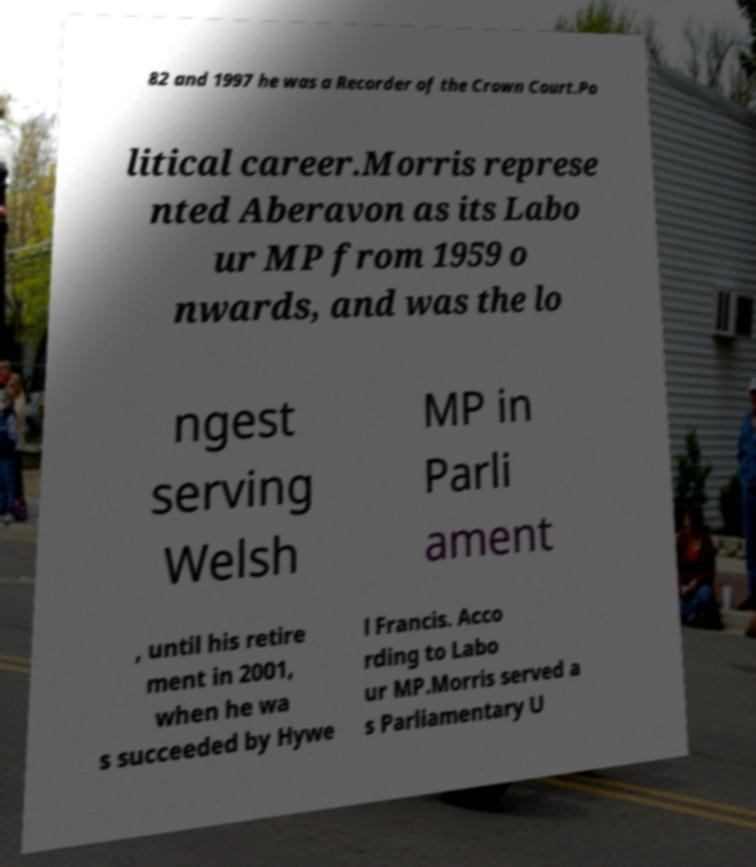I need the written content from this picture converted into text. Can you do that? 82 and 1997 he was a Recorder of the Crown Court.Po litical career.Morris represe nted Aberavon as its Labo ur MP from 1959 o nwards, and was the lo ngest serving Welsh MP in Parli ament , until his retire ment in 2001, when he wa s succeeded by Hywe l Francis. Acco rding to Labo ur MP.Morris served a s Parliamentary U 